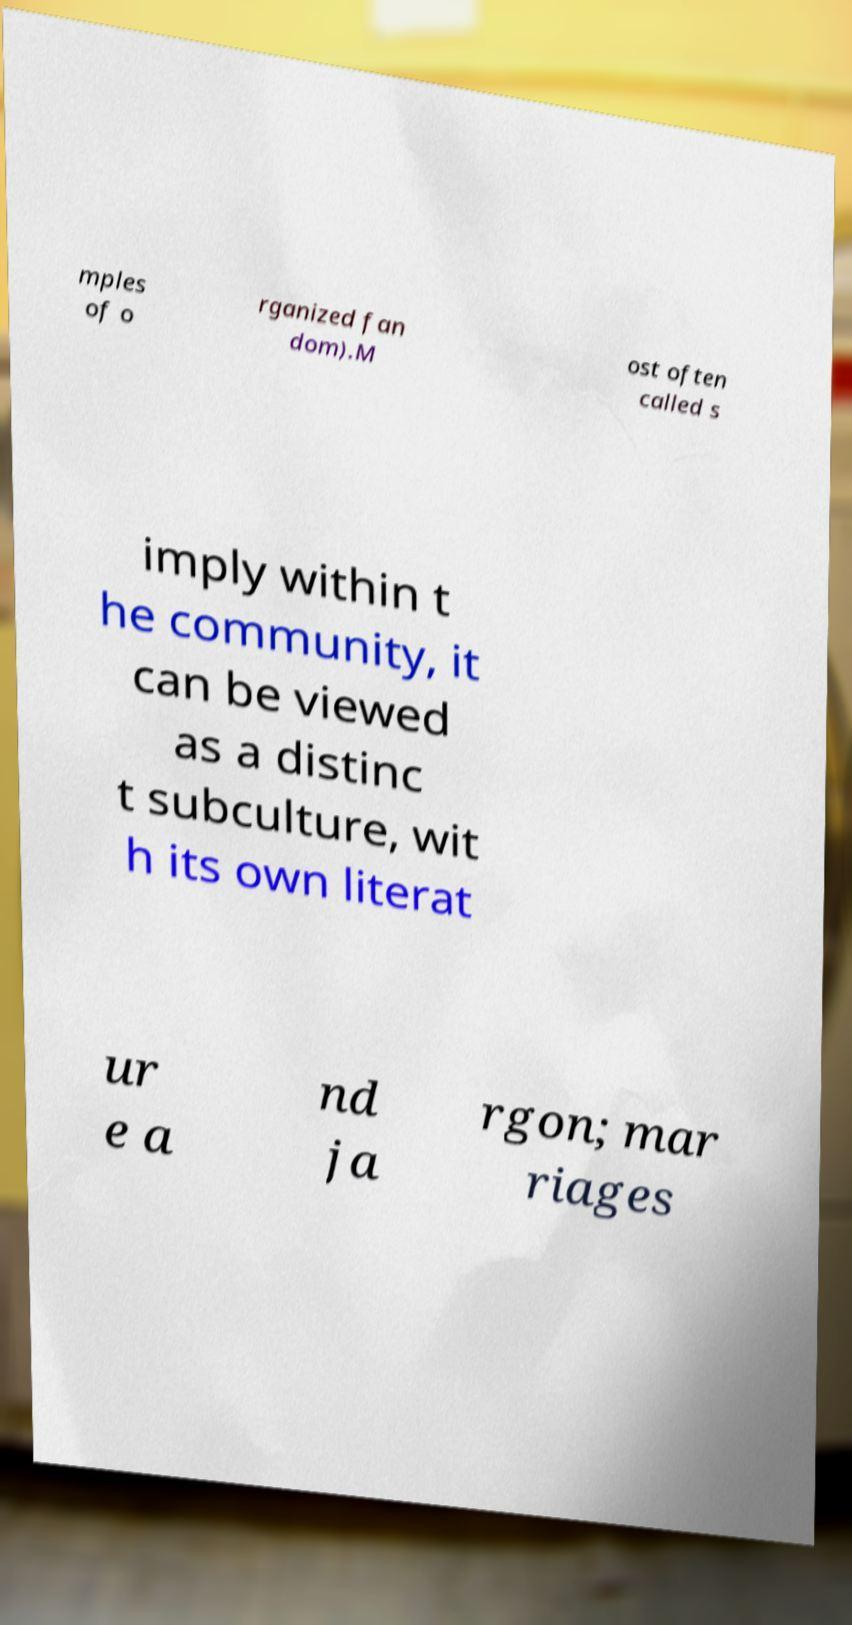Could you extract and type out the text from this image? mples of o rganized fan dom).M ost often called s imply within t he community, it can be viewed as a distinc t subculture, wit h its own literat ur e a nd ja rgon; mar riages 